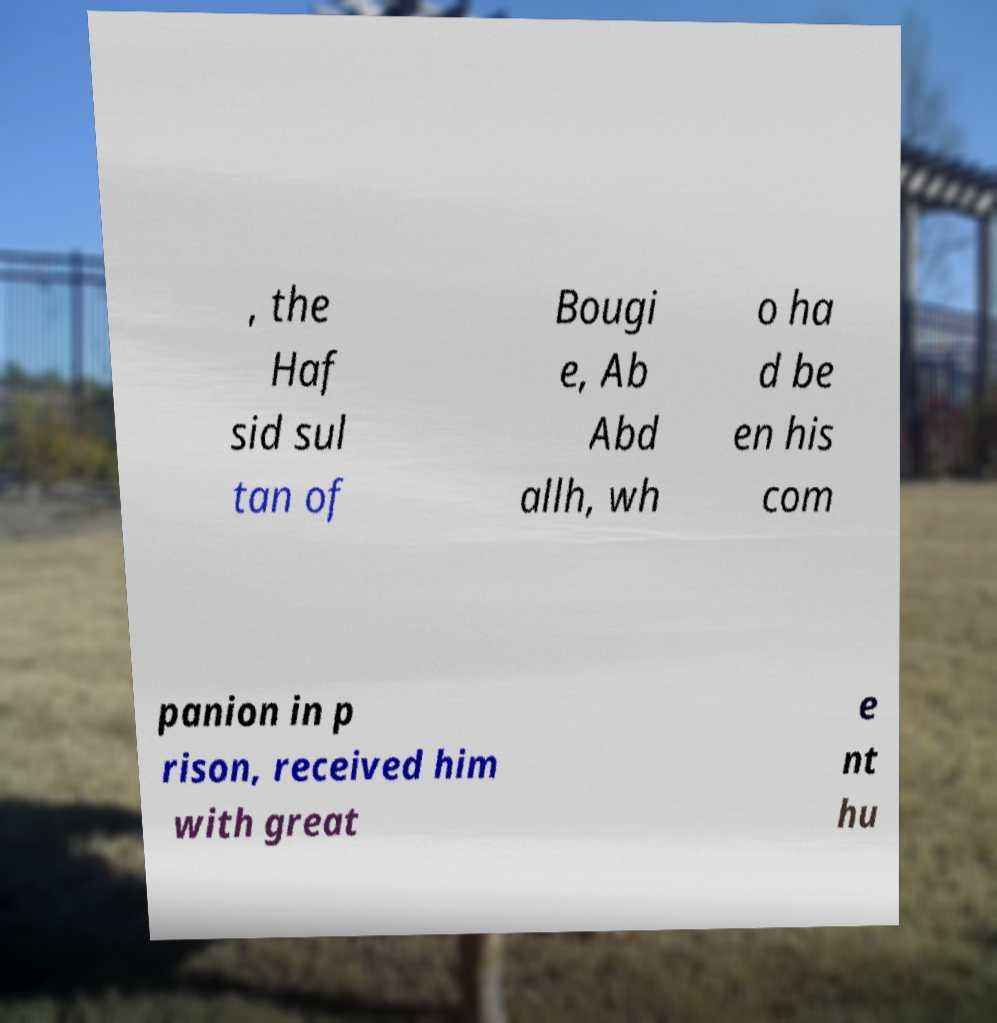Can you accurately transcribe the text from the provided image for me? , the Haf sid sul tan of Bougi e, Ab Abd allh, wh o ha d be en his com panion in p rison, received him with great e nt hu 